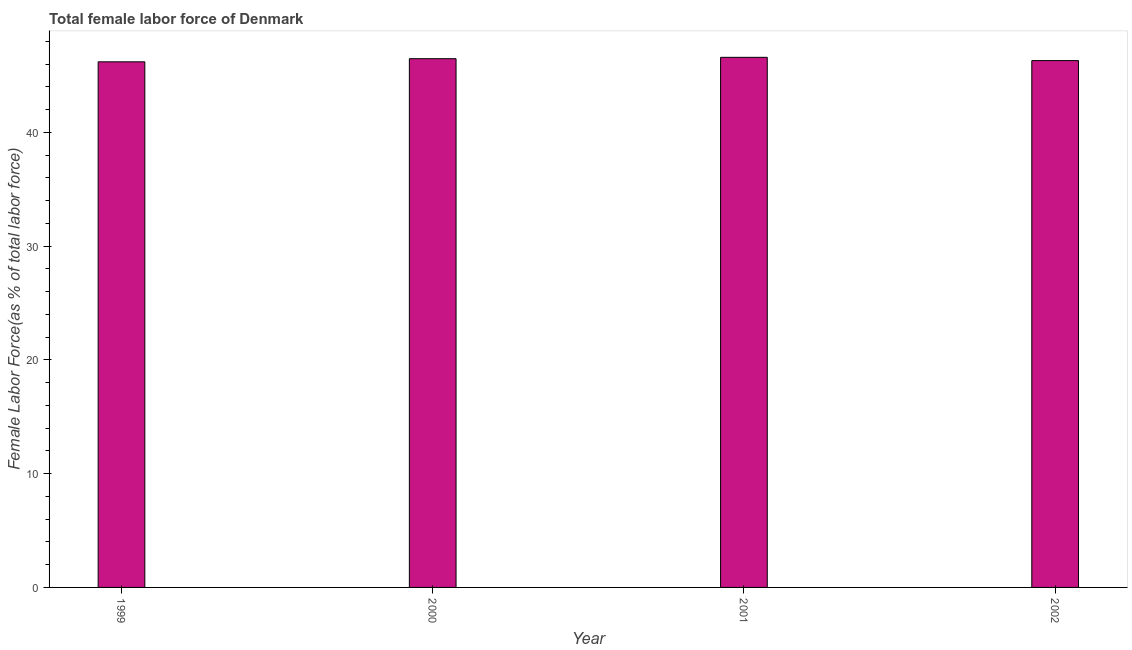Does the graph contain any zero values?
Your answer should be very brief. No. Does the graph contain grids?
Give a very brief answer. No. What is the title of the graph?
Give a very brief answer. Total female labor force of Denmark. What is the label or title of the Y-axis?
Provide a succinct answer. Female Labor Force(as % of total labor force). What is the total female labor force in 2000?
Provide a short and direct response. 46.47. Across all years, what is the maximum total female labor force?
Offer a terse response. 46.6. Across all years, what is the minimum total female labor force?
Keep it short and to the point. 46.2. What is the sum of the total female labor force?
Your answer should be very brief. 185.58. What is the difference between the total female labor force in 2000 and 2002?
Your answer should be compact. 0.17. What is the average total female labor force per year?
Offer a terse response. 46.39. What is the median total female labor force?
Provide a succinct answer. 46.39. Is the difference between the total female labor force in 1999 and 2002 greater than the difference between any two years?
Make the answer very short. No. What is the difference between the highest and the second highest total female labor force?
Give a very brief answer. 0.12. What is the difference between the highest and the lowest total female labor force?
Provide a succinct answer. 0.39. How many bars are there?
Offer a terse response. 4. Are the values on the major ticks of Y-axis written in scientific E-notation?
Ensure brevity in your answer.  No. What is the Female Labor Force(as % of total labor force) of 1999?
Give a very brief answer. 46.2. What is the Female Labor Force(as % of total labor force) of 2000?
Offer a terse response. 46.47. What is the Female Labor Force(as % of total labor force) in 2001?
Offer a very short reply. 46.6. What is the Female Labor Force(as % of total labor force) of 2002?
Your answer should be compact. 46.31. What is the difference between the Female Labor Force(as % of total labor force) in 1999 and 2000?
Offer a terse response. -0.27. What is the difference between the Female Labor Force(as % of total labor force) in 1999 and 2001?
Offer a terse response. -0.39. What is the difference between the Female Labor Force(as % of total labor force) in 1999 and 2002?
Your answer should be compact. -0.11. What is the difference between the Female Labor Force(as % of total labor force) in 2000 and 2001?
Offer a terse response. -0.12. What is the difference between the Female Labor Force(as % of total labor force) in 2000 and 2002?
Give a very brief answer. 0.17. What is the difference between the Female Labor Force(as % of total labor force) in 2001 and 2002?
Keep it short and to the point. 0.29. What is the ratio of the Female Labor Force(as % of total labor force) in 2000 to that in 2001?
Make the answer very short. 1. What is the ratio of the Female Labor Force(as % of total labor force) in 2000 to that in 2002?
Your answer should be very brief. 1. What is the ratio of the Female Labor Force(as % of total labor force) in 2001 to that in 2002?
Your answer should be very brief. 1.01. 